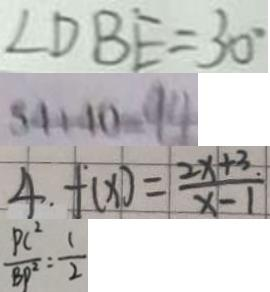Convert formula to latex. <formula><loc_0><loc_0><loc_500><loc_500>\angle D B E = 3 0 ^ { \circ } 
 5 4 + 4 0 = 9 4 
 4 . f ( x ) = \frac { 2 x + 3 . } { x - 1 } 
 \frac { P C ^ { 2 } } { B P ^ { 2 } } = \frac { 1 } { 2 }</formula> 